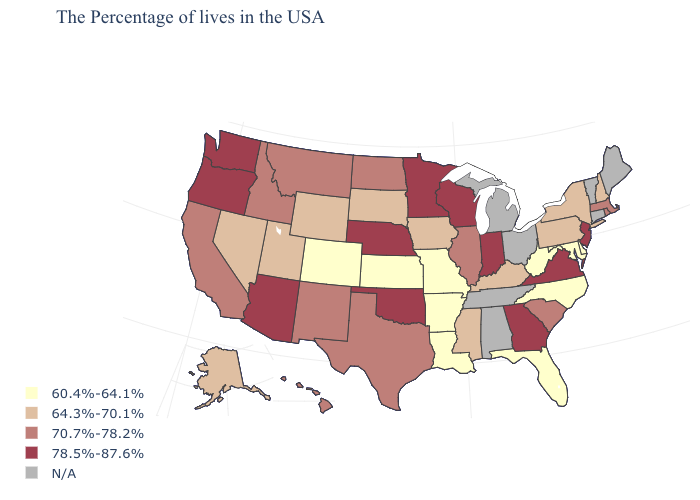Which states hav the highest value in the West?
Answer briefly. Arizona, Washington, Oregon. Does the first symbol in the legend represent the smallest category?
Concise answer only. Yes. Does the map have missing data?
Concise answer only. Yes. What is the value of Colorado?
Be succinct. 60.4%-64.1%. Name the states that have a value in the range 64.3%-70.1%?
Quick response, please. New Hampshire, New York, Pennsylvania, Kentucky, Mississippi, Iowa, South Dakota, Wyoming, Utah, Nevada, Alaska. Does Massachusetts have the highest value in the USA?
Write a very short answer. No. Name the states that have a value in the range 60.4%-64.1%?
Be succinct. Delaware, Maryland, North Carolina, West Virginia, Florida, Louisiana, Missouri, Arkansas, Kansas, Colorado. Does New Jersey have the highest value in the Northeast?
Concise answer only. Yes. How many symbols are there in the legend?
Give a very brief answer. 5. Does New Hampshire have the highest value in the USA?
Concise answer only. No. Name the states that have a value in the range 78.5%-87.6%?
Answer briefly. New Jersey, Virginia, Georgia, Indiana, Wisconsin, Minnesota, Nebraska, Oklahoma, Arizona, Washington, Oregon. What is the highest value in states that border Wisconsin?
Be succinct. 78.5%-87.6%. Name the states that have a value in the range N/A?
Keep it brief. Maine, Vermont, Connecticut, Ohio, Michigan, Alabama, Tennessee. 